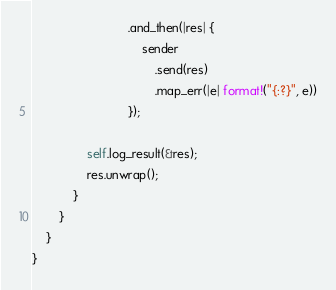Convert code to text. <code><loc_0><loc_0><loc_500><loc_500><_Rust_>                            .and_then(|res| {
                                sender
                                    .send(res)
                                    .map_err(|e| format!("{:?}", e))
                            });

                self.log_result(&res);
                res.unwrap();
            }
        }   
    }
}</code> 